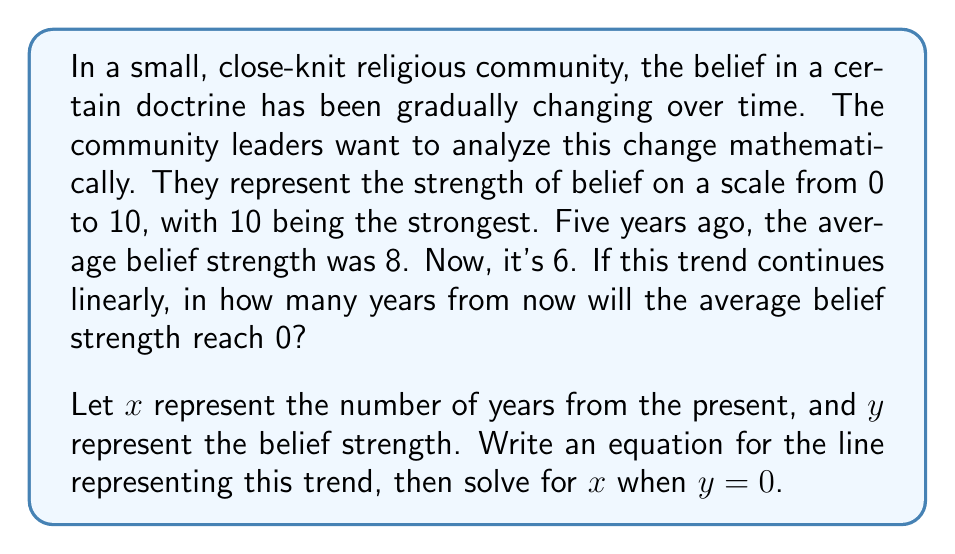Show me your answer to this math problem. To solve this problem, we'll follow these steps:

1) First, let's identify the points we know:
   5 years ago: $(−5, 8)$
   Present: $(0, 6)$

2) We can use these points to calculate the slope of the line:

   $$m = \frac{y_2 - y_1}{x_2 - x_1} = \frac{6 - 8}{0 - (-5)} = \frac{-2}{5} = -0.4$$

3) Now we have the slope and a point $(0, 6)$, we can use the point-slope form of a line to write our equation:

   $$y - y_1 = m(x - x_1)$$
   $$y - 6 = -0.4(x - 0)$$
   $$y - 6 = -0.4x$$

4) Simplify to slope-intercept form:

   $$y = -0.4x + 6$$

5) To find when the belief strength reaches 0, we set $y = 0$ and solve for $x$:

   $$0 = -0.4x + 6$$
   $$0.4x = 6$$
   $$x = \frac{6}{0.4} = 15$$

Therefore, if the trend continues linearly, the average belief strength will reach 0 in 15 years from now.
Answer: 15 years 